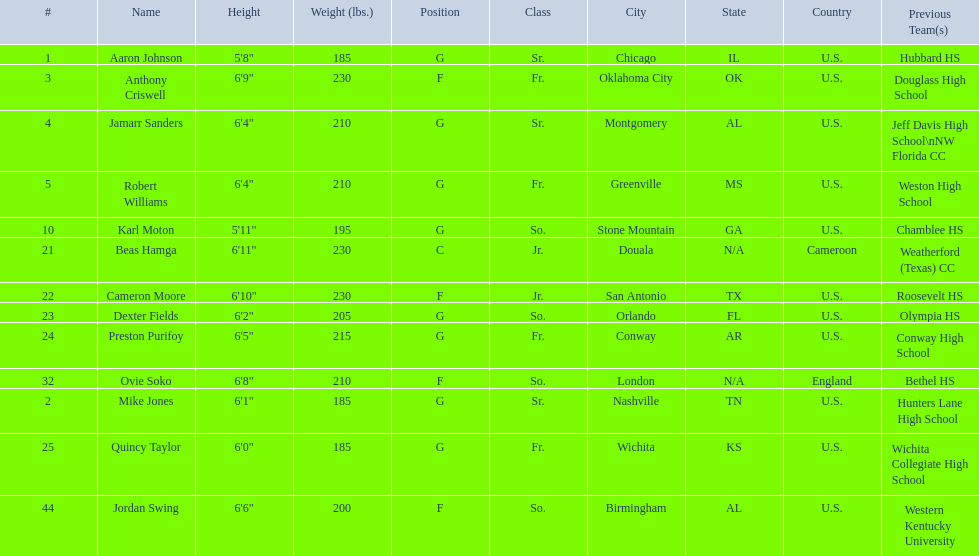Which are all of the players? Aaron Johnson, Anthony Criswell, Jamarr Sanders, Robert Williams, Karl Moton, Beas Hamga, Cameron Moore, Dexter Fields, Preston Purifoy, Ovie Soko, Mike Jones, Quincy Taylor, Jordan Swing. Which players are from a country outside of the u.s.? Beas Hamga, Ovie Soko. Aside from soko, who else is not from the u.s.? Beas Hamga. 